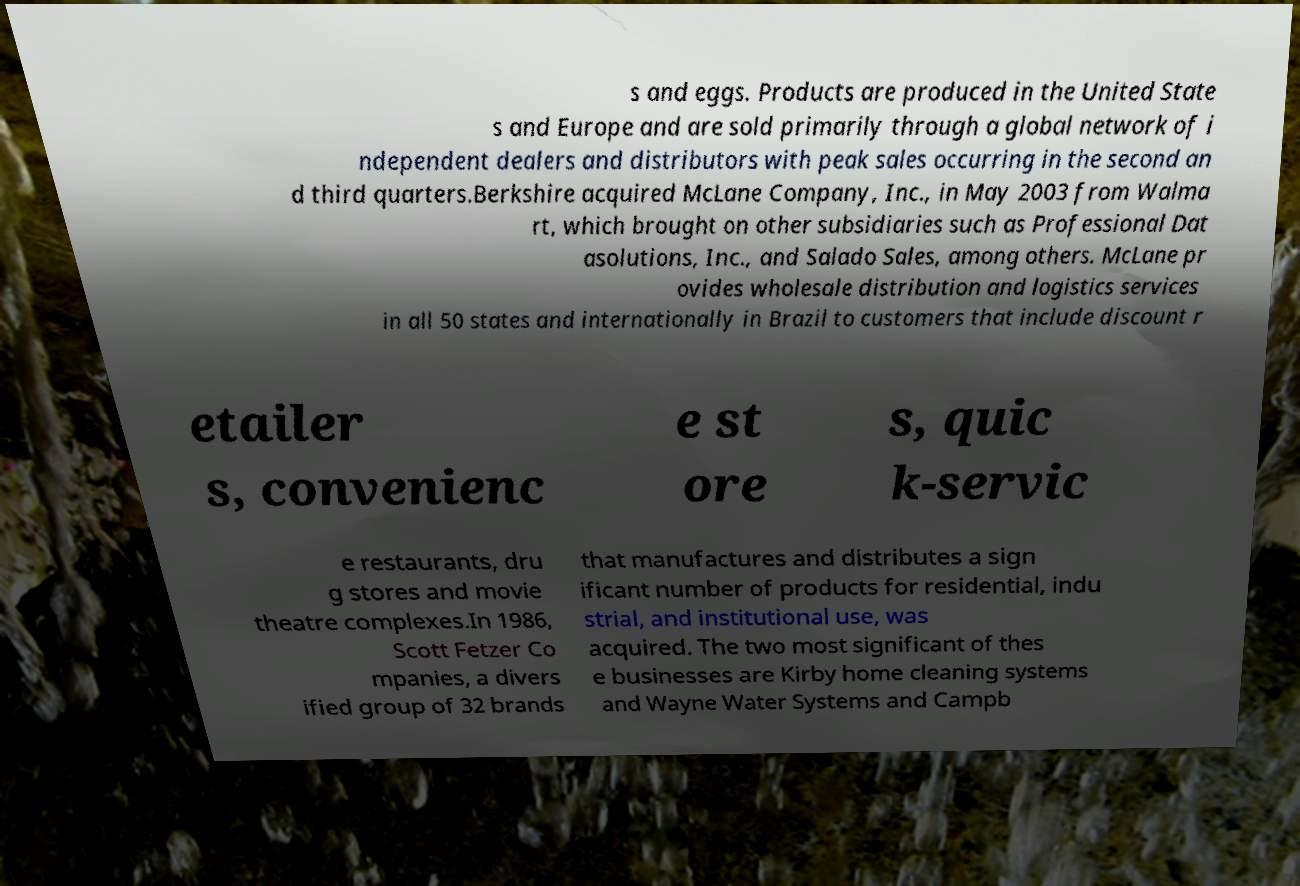There's text embedded in this image that I need extracted. Can you transcribe it verbatim? s and eggs. Products are produced in the United State s and Europe and are sold primarily through a global network of i ndependent dealers and distributors with peak sales occurring in the second an d third quarters.Berkshire acquired McLane Company, Inc., in May 2003 from Walma rt, which brought on other subsidiaries such as Professional Dat asolutions, Inc., and Salado Sales, among others. McLane pr ovides wholesale distribution and logistics services in all 50 states and internationally in Brazil to customers that include discount r etailer s, convenienc e st ore s, quic k-servic e restaurants, dru g stores and movie theatre complexes.In 1986, Scott Fetzer Co mpanies, a divers ified group of 32 brands that manufactures and distributes a sign ificant number of products for residential, indu strial, and institutional use, was acquired. The two most significant of thes e businesses are Kirby home cleaning systems and Wayne Water Systems and Campb 